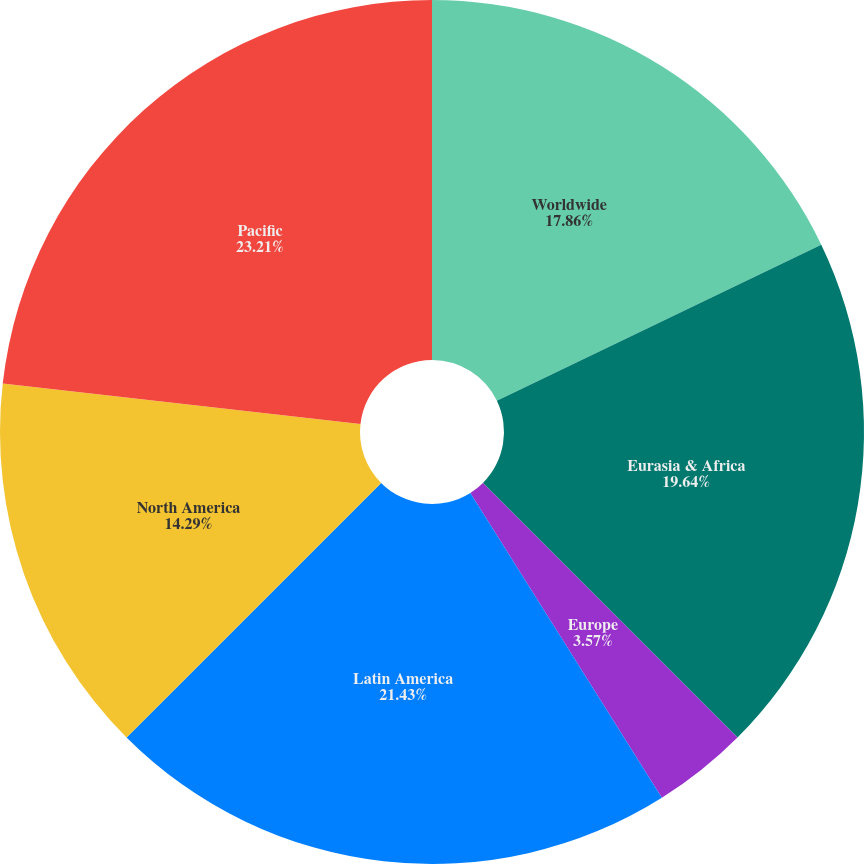Convert chart to OTSL. <chart><loc_0><loc_0><loc_500><loc_500><pie_chart><fcel>Worldwide<fcel>Eurasia & Africa<fcel>Europe<fcel>Latin America<fcel>North America<fcel>Pacific<nl><fcel>17.86%<fcel>19.64%<fcel>3.57%<fcel>21.43%<fcel>14.29%<fcel>23.21%<nl></chart> 